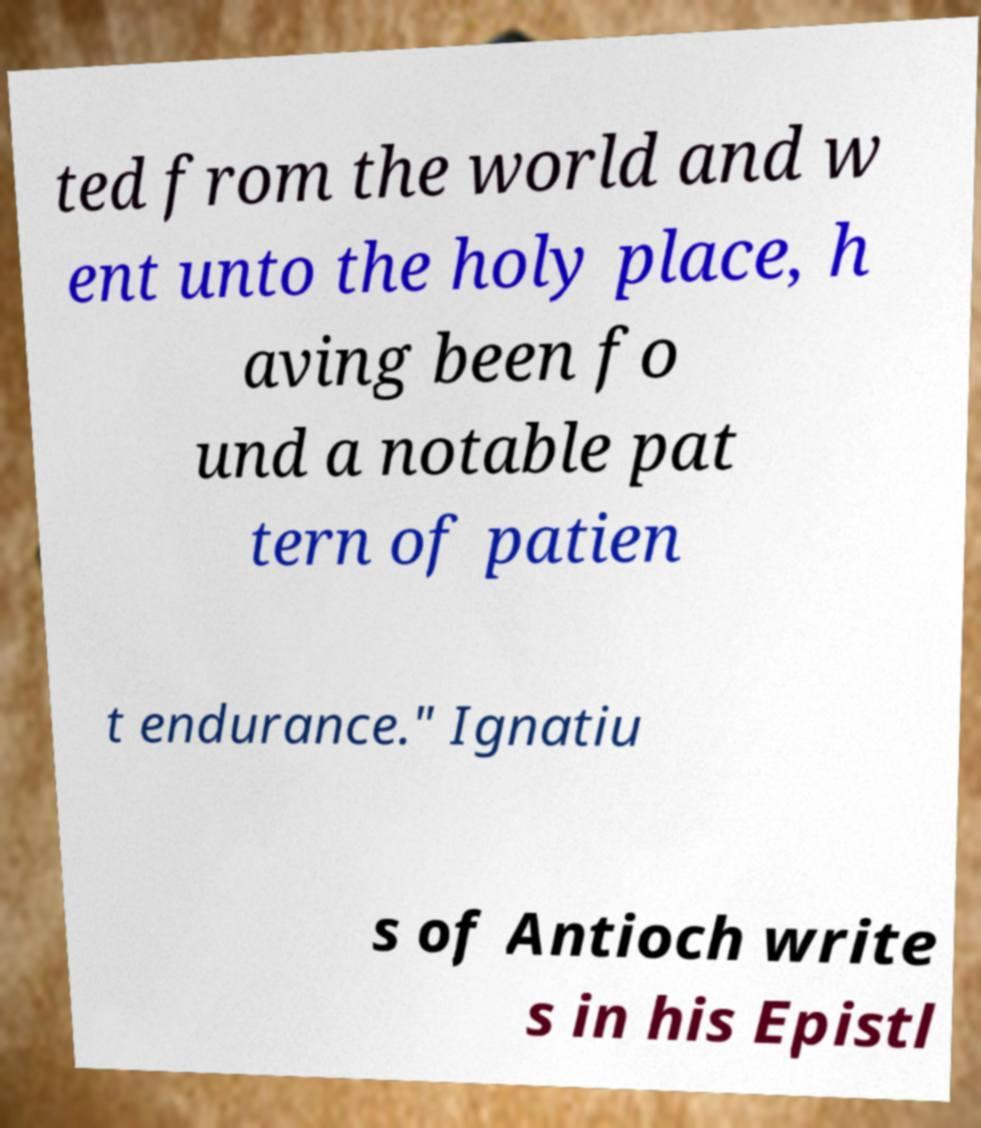For documentation purposes, I need the text within this image transcribed. Could you provide that? ted from the world and w ent unto the holy place, h aving been fo und a notable pat tern of patien t endurance." Ignatiu s of Antioch write s in his Epistl 